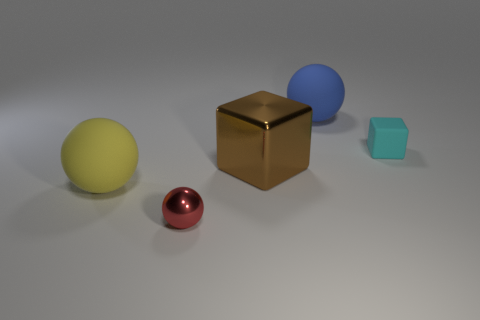Can you describe the lighting in the scene? The scene is lit by soft, diffuse overhead lighting which casts subtle shadows beneath each object, suggesting an indoor setting with an ambient light source. The reflections on the surfaces of the metallic spheres and the golden cube hint at the existence of a light source above them, and the lack of dramatic contrasts indicates that the light is neither excessively bright nor directional. 